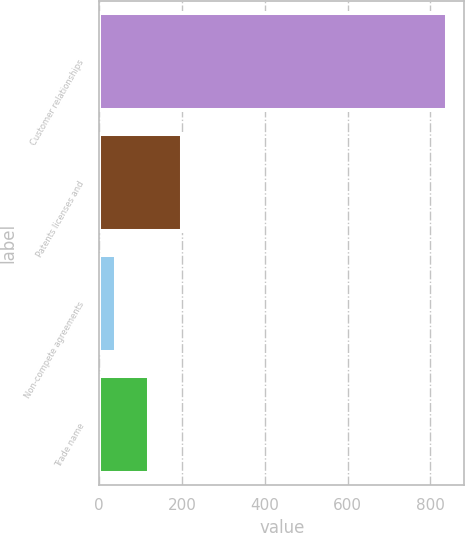Convert chart. <chart><loc_0><loc_0><loc_500><loc_500><bar_chart><fcel>Customer relationships<fcel>Patents licenses and<fcel>Non-compete agreements<fcel>Trade name<nl><fcel>839.8<fcel>199.48<fcel>39.4<fcel>119.44<nl></chart> 